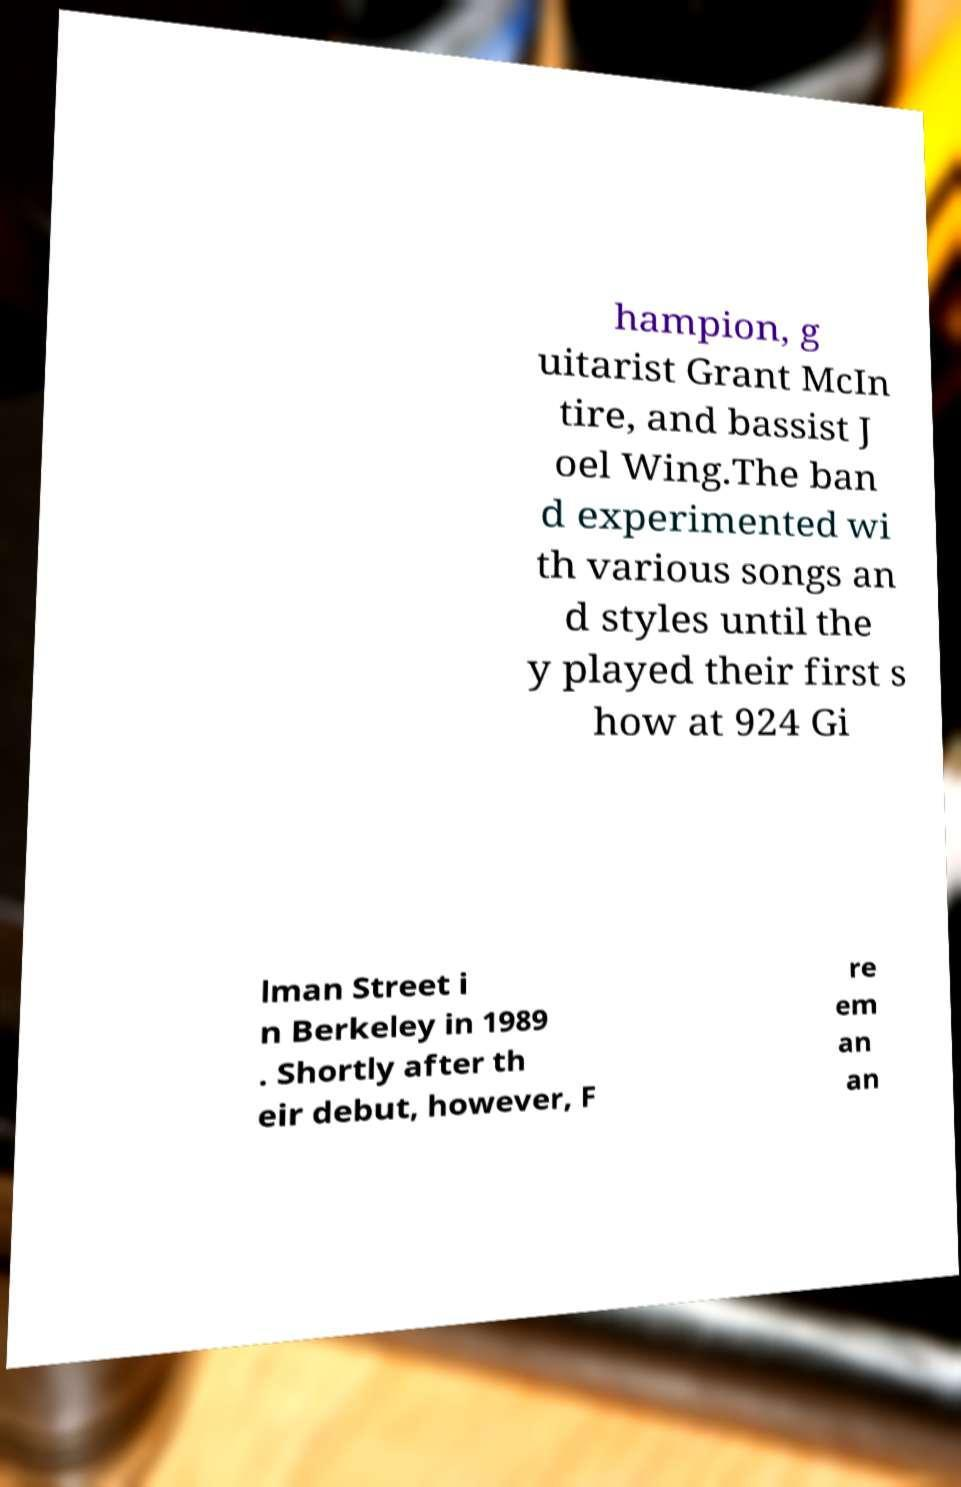There's text embedded in this image that I need extracted. Can you transcribe it verbatim? hampion, g uitarist Grant McIn tire, and bassist J oel Wing.The ban d experimented wi th various songs an d styles until the y played their first s how at 924 Gi lman Street i n Berkeley in 1989 . Shortly after th eir debut, however, F re em an an 